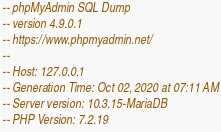Convert code to text. <code><loc_0><loc_0><loc_500><loc_500><_SQL_>-- phpMyAdmin SQL Dump
-- version 4.9.0.1
-- https://www.phpmyadmin.net/
--
-- Host: 127.0.0.1
-- Generation Time: Oct 02, 2020 at 07:11 AM
-- Server version: 10.3.15-MariaDB
-- PHP Version: 7.2.19
</code> 